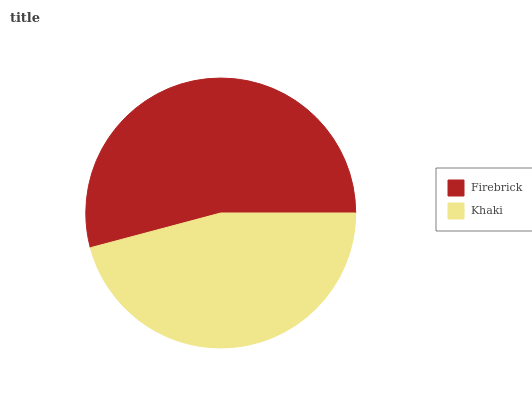Is Khaki the minimum?
Answer yes or no. Yes. Is Firebrick the maximum?
Answer yes or no. Yes. Is Khaki the maximum?
Answer yes or no. No. Is Firebrick greater than Khaki?
Answer yes or no. Yes. Is Khaki less than Firebrick?
Answer yes or no. Yes. Is Khaki greater than Firebrick?
Answer yes or no. No. Is Firebrick less than Khaki?
Answer yes or no. No. Is Firebrick the high median?
Answer yes or no. Yes. Is Khaki the low median?
Answer yes or no. Yes. Is Khaki the high median?
Answer yes or no. No. Is Firebrick the low median?
Answer yes or no. No. 